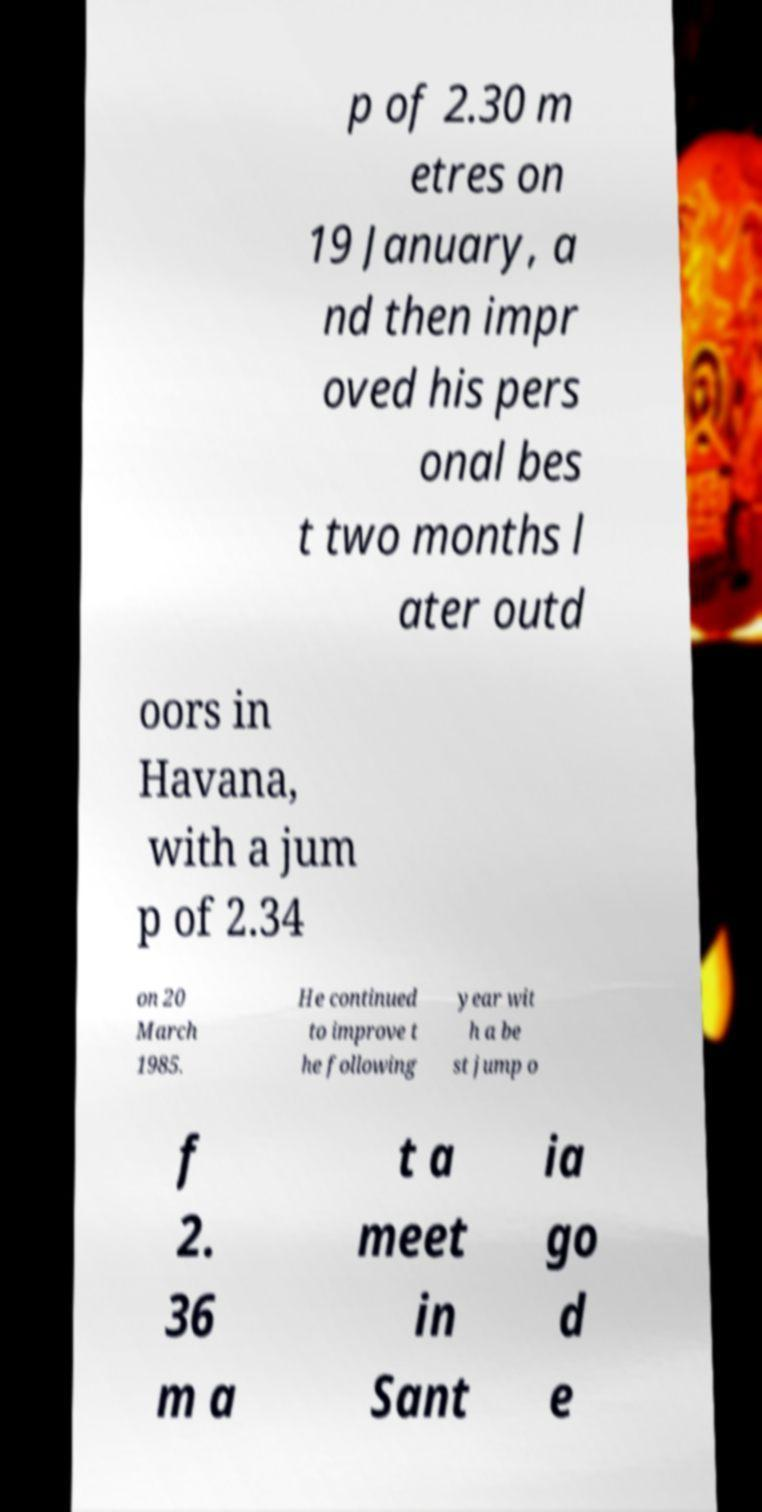I need the written content from this picture converted into text. Can you do that? p of 2.30 m etres on 19 January, a nd then impr oved his pers onal bes t two months l ater outd oors in Havana, with a jum p of 2.34 on 20 March 1985. He continued to improve t he following year wit h a be st jump o f 2. 36 m a t a meet in Sant ia go d e 